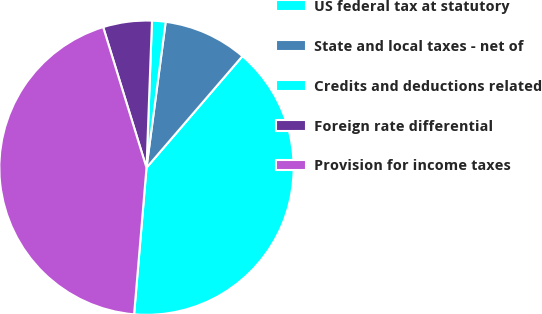Convert chart to OTSL. <chart><loc_0><loc_0><loc_500><loc_500><pie_chart><fcel>US federal tax at statutory<fcel>State and local taxes - net of<fcel>Credits and deductions related<fcel>Foreign rate differential<fcel>Provision for income taxes<nl><fcel>40.04%<fcel>9.22%<fcel>1.49%<fcel>5.35%<fcel>43.9%<nl></chart> 